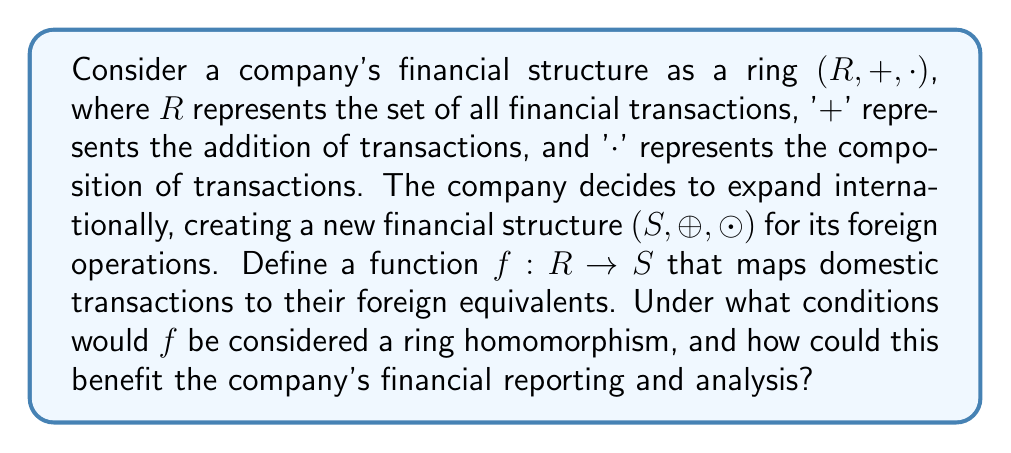Can you solve this math problem? To analyze this problem, we need to consider the properties of ring homomorphisms and how they apply to the business context:

1. Preservation of addition:
   For a ring homomorphism, we must have $f(a + b) = f(a) \oplus f(b)$ for all $a, b \in R$.
   In the business context, this means that the sum of two domestic transactions should map to the sum of their foreign equivalents.

2. Preservation of multiplication:
   For a ring homomorphism, we must have $f(a \cdot b) = f(a) \odot f(b)$ for all $a, b \in R$.
   In the business context, this means that the composition of two domestic transactions should map to the composition of their foreign equivalents.

3. Preservation of identity elements:
   The additive identity (0) and multiplicative identity (1) should be preserved:
   $f(0_R) = 0_S$ and $f(1_R) = 1_S$

For $f$ to be a ring homomorphism, all these conditions must be satisfied. 

Benefits for the company:

1. Consistency in financial reporting: A ring homomorphism ensures that arithmetic operations on transactions are consistent between domestic and foreign operations, simplifying consolidation of financial statements.

2. Improved analysis: The structural preservation allows for easier comparison and analysis of financial data across different markets.

3. Streamlined operations: The homomorphism property can be used to design more efficient financial systems that work consistently across different branches of the company.

4. Risk management: The preservation of structure can help in identifying and managing financial risks consistently across different markets.

5. Compliance: A well-defined mapping between domestic and foreign transactions can aid in regulatory compliance and auditing processes.

To fully benefit from this structure, the company should ensure that their financial systems and processes are designed to maintain these homomorphism properties. This may involve careful consideration of currency conversions, tax implications, and local financial regulations when defining the mapping function $f$.
Answer: For $f: R \rightarrow S$ to be a ring homomorphism, it must satisfy:

1. $f(a + b) = f(a) \oplus f(b)$ for all $a, b \in R$
2. $f(a \cdot b) = f(a) \odot f(b)$ for all $a, b \in R$
3. $f(0_R) = 0_S$ and $f(1_R) = 1_S$

These conditions ensure consistent mapping of financial transactions between domestic and foreign operations, benefiting the company through improved financial reporting, analysis, risk management, and compliance. 